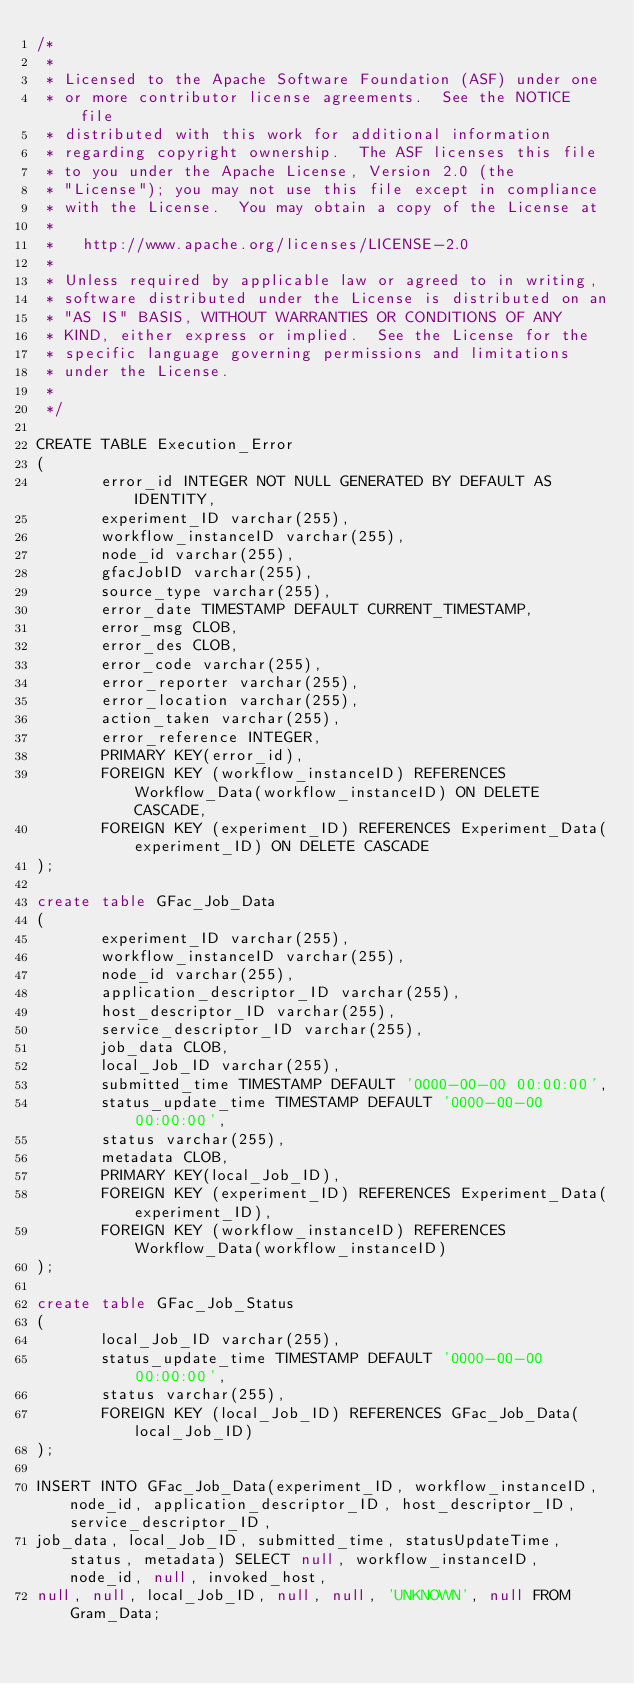<code> <loc_0><loc_0><loc_500><loc_500><_SQL_>/*
 *
 * Licensed to the Apache Software Foundation (ASF) under one
 * or more contributor license agreements.  See the NOTICE file
 * distributed with this work for additional information
 * regarding copyright ownership.  The ASF licenses this file
 * to you under the Apache License, Version 2.0 (the
 * "License"); you may not use this file except in compliance
 * with the License.  You may obtain a copy of the License at
 *
 *   http://www.apache.org/licenses/LICENSE-2.0
 *
 * Unless required by applicable law or agreed to in writing,
 * software distributed under the License is distributed on an
 * "AS IS" BASIS, WITHOUT WARRANTIES OR CONDITIONS OF ANY
 * KIND, either express or implied.  See the License for the
 * specific language governing permissions and limitations
 * under the License.
 *
 */

CREATE TABLE Execution_Error
(
       error_id INTEGER NOT NULL GENERATED BY DEFAULT AS IDENTITY,
       experiment_ID varchar(255),
       workflow_instanceID varchar(255),
       node_id varchar(255),
       gfacJobID varchar(255),
       source_type varchar(255),
       error_date TIMESTAMP DEFAULT CURRENT_TIMESTAMP,
       error_msg CLOB,
       error_des CLOB,
       error_code varchar(255),
       error_reporter varchar(255),
       error_location varchar(255),
       action_taken varchar(255),
       error_reference INTEGER,
       PRIMARY KEY(error_id),
       FOREIGN KEY (workflow_instanceID) REFERENCES Workflow_Data(workflow_instanceID) ON DELETE CASCADE,
       FOREIGN KEY (experiment_ID) REFERENCES Experiment_Data(experiment_ID) ON DELETE CASCADE
);

create table GFac_Job_Data
(
       experiment_ID varchar(255),
       workflow_instanceID varchar(255),
       node_id varchar(255),
       application_descriptor_ID varchar(255),
       host_descriptor_ID varchar(255),
       service_descriptor_ID varchar(255),
       job_data CLOB,
       local_Job_ID varchar(255),
       submitted_time TIMESTAMP DEFAULT '0000-00-00 00:00:00',
       status_update_time TIMESTAMP DEFAULT '0000-00-00 00:00:00',
       status varchar(255),
       metadata CLOB,
       PRIMARY KEY(local_Job_ID),
       FOREIGN KEY (experiment_ID) REFERENCES Experiment_Data(experiment_ID),
       FOREIGN KEY (workflow_instanceID) REFERENCES Workflow_Data(workflow_instanceID)
);

create table GFac_Job_Status
(
       local_Job_ID varchar(255),
       status_update_time TIMESTAMP DEFAULT '0000-00-00 00:00:00',
       status varchar(255),
       FOREIGN KEY (local_Job_ID) REFERENCES GFac_Job_Data(local_Job_ID)
);

INSERT INTO GFac_Job_Data(experiment_ID, workflow_instanceID, node_id, application_descriptor_ID, host_descriptor_ID, service_descriptor_ID,
job_data, local_Job_ID, submitted_time, statusUpdateTime, status, metadata) SELECT null, workflow_instanceID, node_id, null, invoked_host,
null, null, local_Job_ID, null, null, 'UNKNOWN', null FROM Gram_Data;</code> 